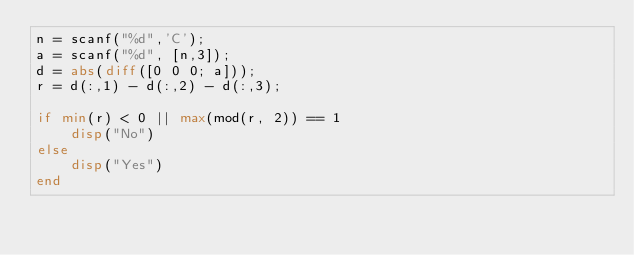Convert code to text. <code><loc_0><loc_0><loc_500><loc_500><_Octave_>n = scanf("%d",'C');
a = scanf("%d", [n,3]);
d = abs(diff([0 0 0; a]));
r = d(:,1) - d(:,2) - d(:,3);
 
if min(r) < 0 || max(mod(r, 2)) == 1
    disp("No")
else
    disp("Yes")
end
</code> 